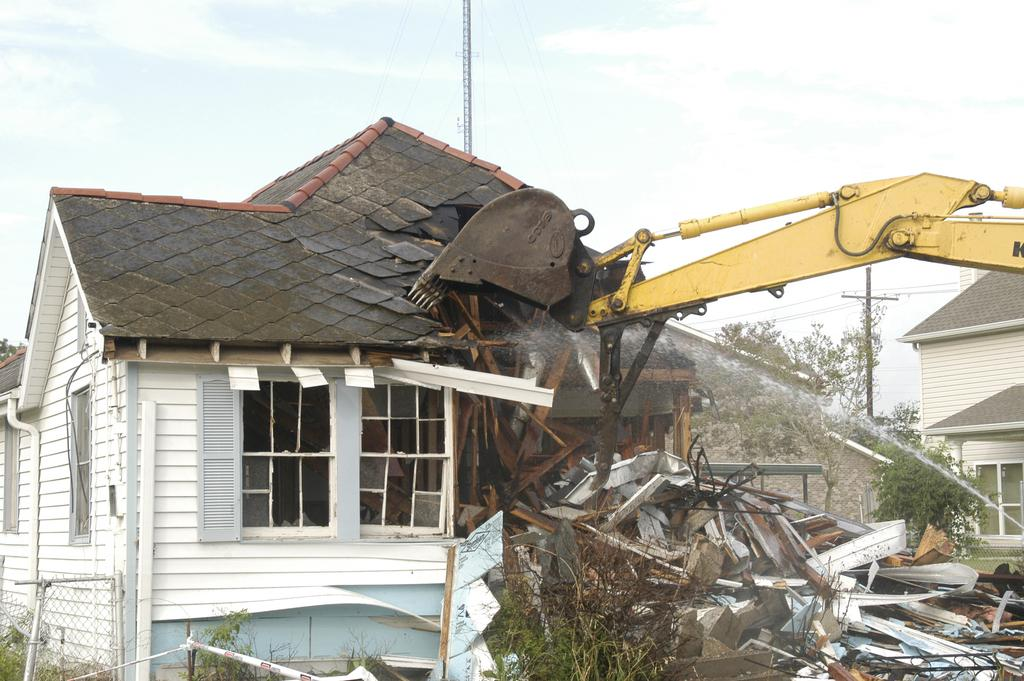What is the crane doing in the image? The crane is excavating a building on the right side of the image. What can be seen in the background of the image? There are trees, poles, a shed, and a fence in the background of the image. What is visible in the sky in the image? The sky is visible in the background of the image. What type of record can be seen being played on a turntable in the image? There is no turntable or record present in the image. How many shops are visible in the image? There are no shops visible in the image. 